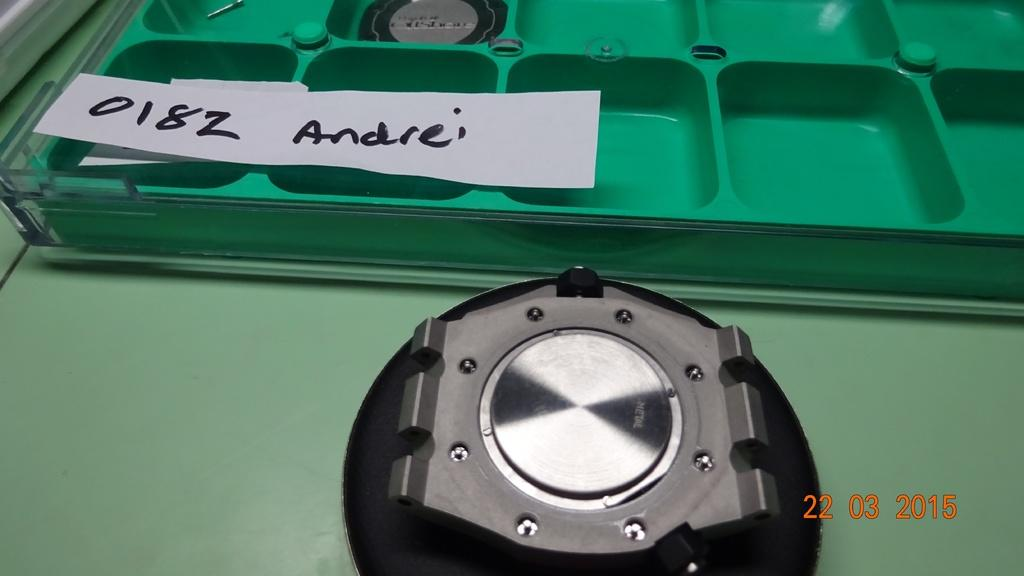What is the color of the object that stands out in the image? There is a green color object in the image. What else can be seen in the image besides the green object? There are other objects in the image. Can you describe the paper in the image? There is a paper in the image, and something is written on it. What additional detail can be observed about the paper? There is a watermark on the paper. How does the bell begin to jump in the image? There is no bell present in the image, so it cannot begin to jump. 